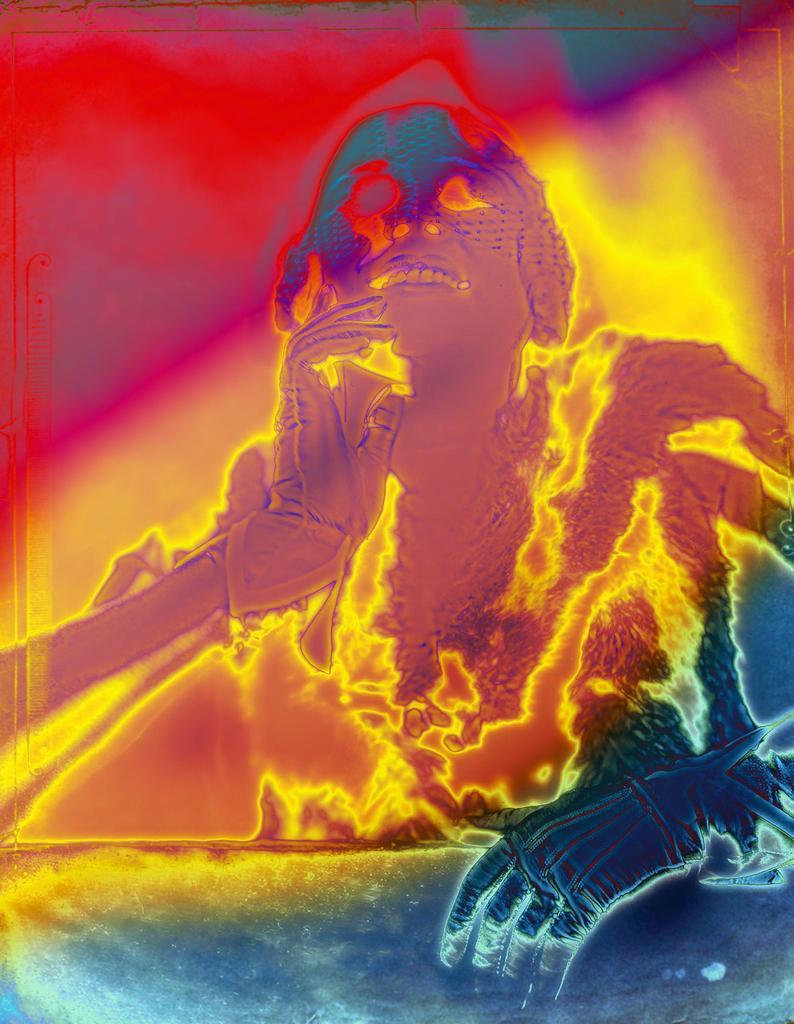Could you give a brief overview of what you see in this image? In this image there is a graphic picture of a woman. 